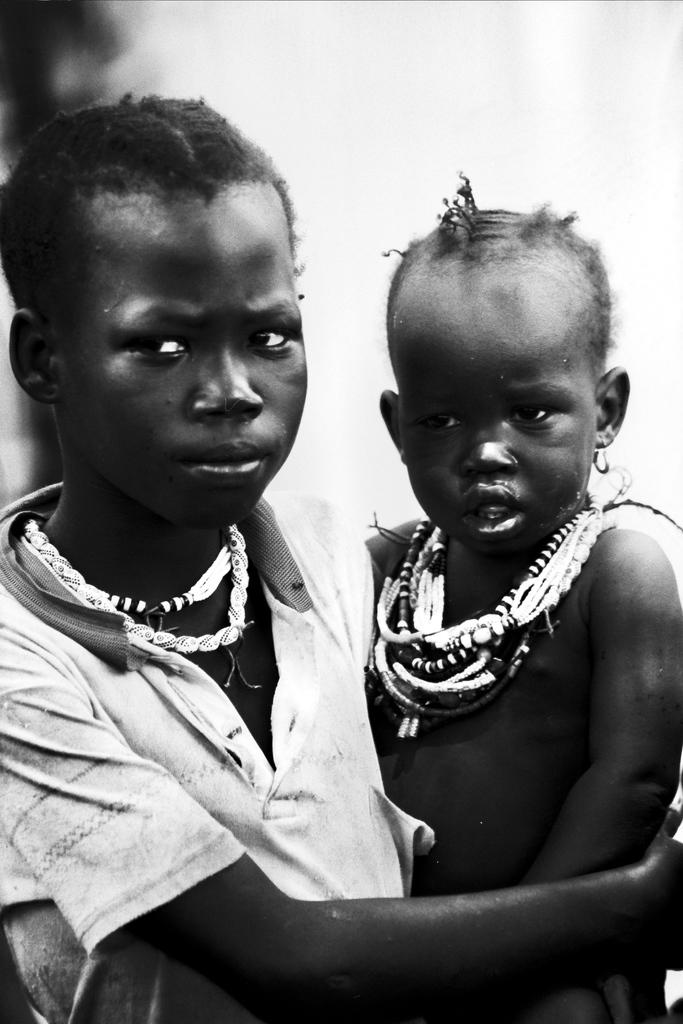What is happening in the image? There is a person standing in the image, holding a kid. Can you describe the person in the image? The person is holding a kid, but their appearance cannot be clearly discerned due to the blurred background. What is the overall appearance of the image? The background of the image is blurred. What type of clover can be seen growing in the image? There is no clover present in the image; it features a person holding a kid with a blurred background. How does the goose interact with the person holding the kid in the image? There is no goose present in the image; it only features a person holding a kid with a blurred background. 